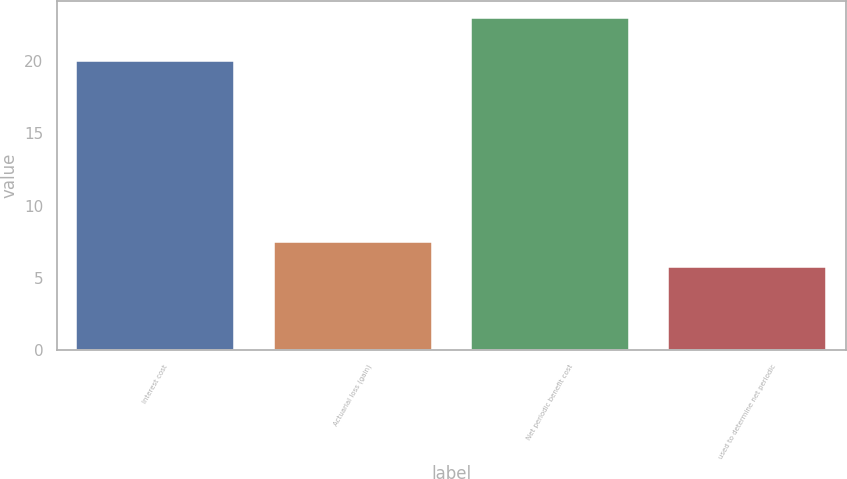Convert chart. <chart><loc_0><loc_0><loc_500><loc_500><bar_chart><fcel>Interest cost<fcel>Actuarial loss (gain)<fcel>Net periodic benefit cost<fcel>used to determine net periodic<nl><fcel>20<fcel>7.47<fcel>23<fcel>5.75<nl></chart> 